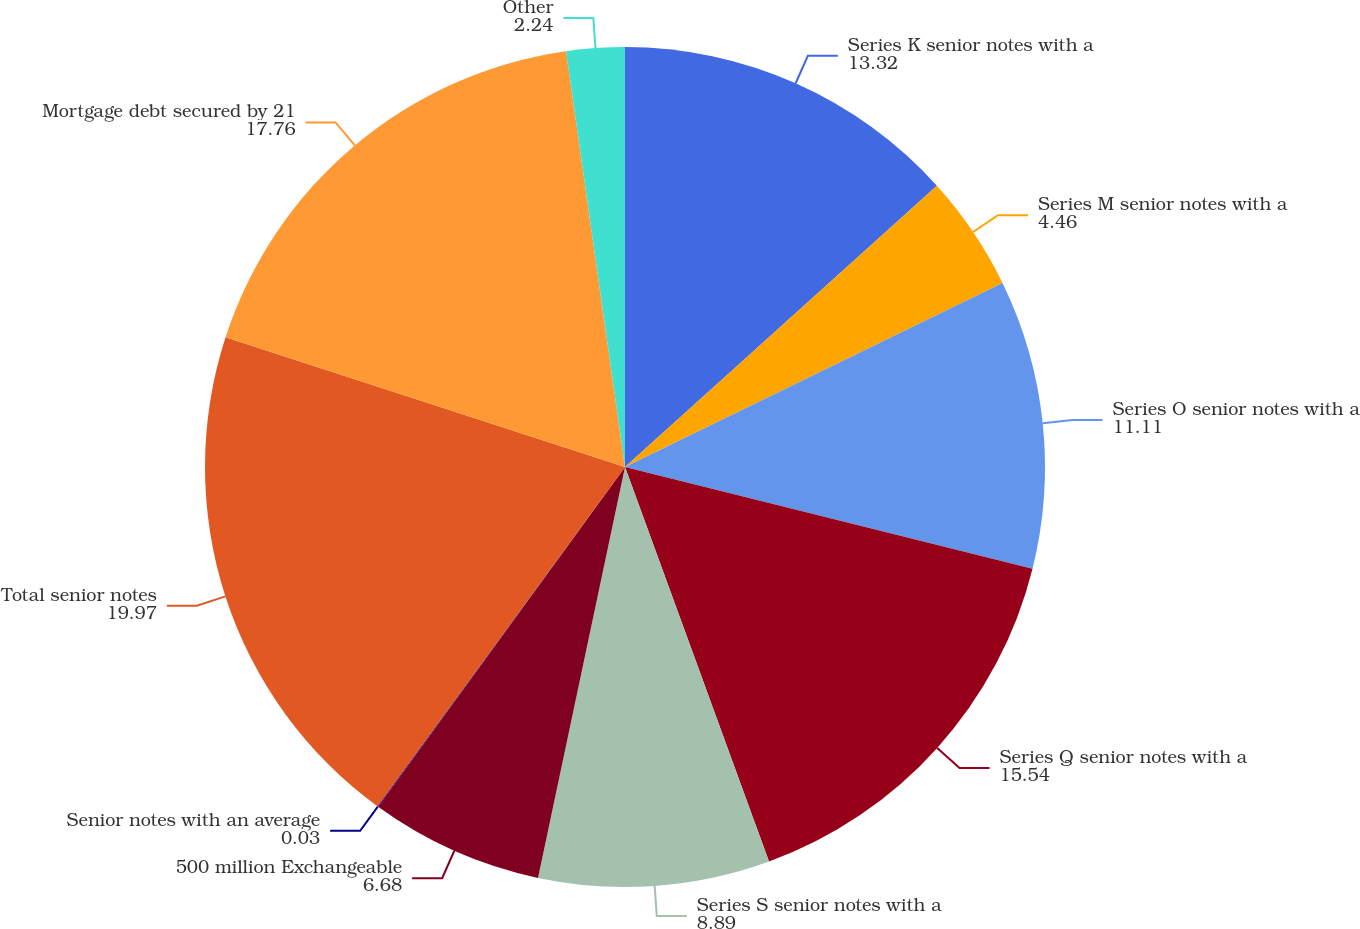Convert chart to OTSL. <chart><loc_0><loc_0><loc_500><loc_500><pie_chart><fcel>Series K senior notes with a<fcel>Series M senior notes with a<fcel>Series O senior notes with a<fcel>Series Q senior notes with a<fcel>Series S senior notes with a<fcel>500 million Exchangeable<fcel>Senior notes with an average<fcel>Total senior notes<fcel>Mortgage debt secured by 21<fcel>Other<nl><fcel>13.32%<fcel>4.46%<fcel>11.11%<fcel>15.54%<fcel>8.89%<fcel>6.68%<fcel>0.03%<fcel>19.97%<fcel>17.76%<fcel>2.24%<nl></chart> 